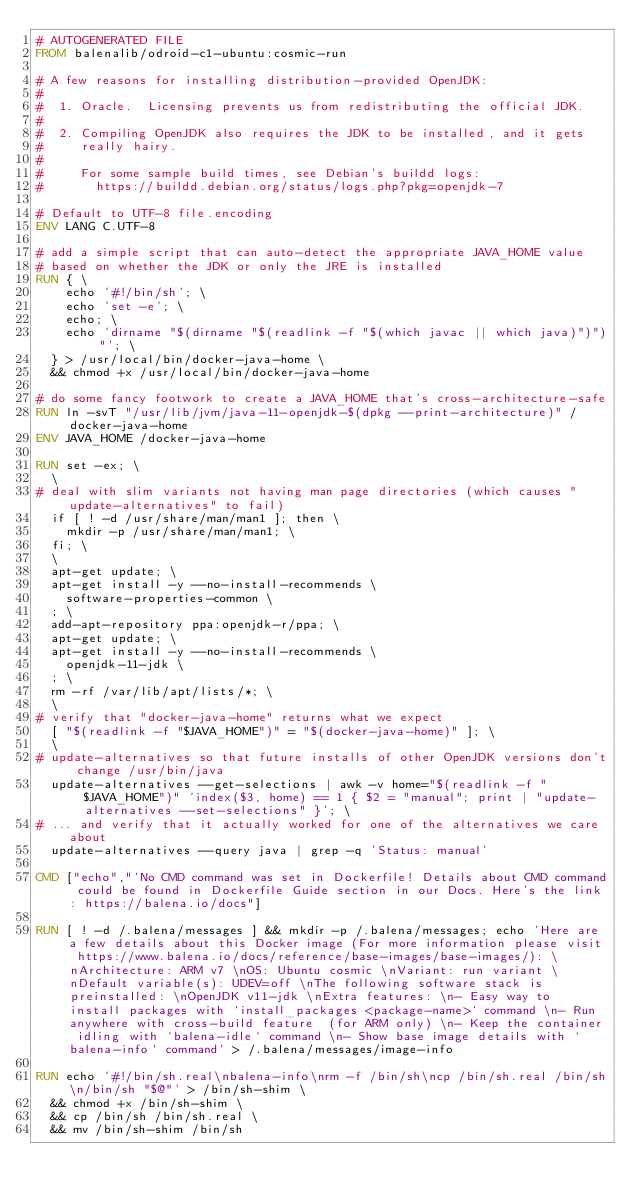<code> <loc_0><loc_0><loc_500><loc_500><_Dockerfile_># AUTOGENERATED FILE
FROM balenalib/odroid-c1-ubuntu:cosmic-run

# A few reasons for installing distribution-provided OpenJDK:
#
#  1. Oracle.  Licensing prevents us from redistributing the official JDK.
#
#  2. Compiling OpenJDK also requires the JDK to be installed, and it gets
#     really hairy.
#
#     For some sample build times, see Debian's buildd logs:
#       https://buildd.debian.org/status/logs.php?pkg=openjdk-7

# Default to UTF-8 file.encoding
ENV LANG C.UTF-8

# add a simple script that can auto-detect the appropriate JAVA_HOME value
# based on whether the JDK or only the JRE is installed
RUN { \
		echo '#!/bin/sh'; \
		echo 'set -e'; \
		echo; \
		echo 'dirname "$(dirname "$(readlink -f "$(which javac || which java)")")"'; \
	} > /usr/local/bin/docker-java-home \
	&& chmod +x /usr/local/bin/docker-java-home

# do some fancy footwork to create a JAVA_HOME that's cross-architecture-safe
RUN ln -svT "/usr/lib/jvm/java-11-openjdk-$(dpkg --print-architecture)" /docker-java-home
ENV JAVA_HOME /docker-java-home

RUN set -ex; \
	\
# deal with slim variants not having man page directories (which causes "update-alternatives" to fail)
	if [ ! -d /usr/share/man/man1 ]; then \
		mkdir -p /usr/share/man/man1; \
	fi; \
	\
	apt-get update; \
	apt-get install -y --no-install-recommends \
		software-properties-common \
	; \
	add-apt-repository ppa:openjdk-r/ppa; \
	apt-get update; \
	apt-get install -y --no-install-recommends \
		openjdk-11-jdk \
	; \
	rm -rf /var/lib/apt/lists/*; \
	\
# verify that "docker-java-home" returns what we expect
	[ "$(readlink -f "$JAVA_HOME")" = "$(docker-java-home)" ]; \
	\
# update-alternatives so that future installs of other OpenJDK versions don't change /usr/bin/java
	update-alternatives --get-selections | awk -v home="$(readlink -f "$JAVA_HOME")" 'index($3, home) == 1 { $2 = "manual"; print | "update-alternatives --set-selections" }'; \
# ... and verify that it actually worked for one of the alternatives we care about
	update-alternatives --query java | grep -q 'Status: manual'

CMD ["echo","'No CMD command was set in Dockerfile! Details about CMD command could be found in Dockerfile Guide section in our Docs. Here's the link: https://balena.io/docs"]

RUN [ ! -d /.balena/messages ] && mkdir -p /.balena/messages; echo 'Here are a few details about this Docker image (For more information please visit https://www.balena.io/docs/reference/base-images/base-images/): \nArchitecture: ARM v7 \nOS: Ubuntu cosmic \nVariant: run variant \nDefault variable(s): UDEV=off \nThe following software stack is preinstalled: \nOpenJDK v11-jdk \nExtra features: \n- Easy way to install packages with `install_packages <package-name>` command \n- Run anywhere with cross-build feature  (for ARM only) \n- Keep the container idling with `balena-idle` command \n- Show base image details with `balena-info` command' > /.balena/messages/image-info

RUN echo '#!/bin/sh.real\nbalena-info\nrm -f /bin/sh\ncp /bin/sh.real /bin/sh\n/bin/sh "$@"' > /bin/sh-shim \
	&& chmod +x /bin/sh-shim \
	&& cp /bin/sh /bin/sh.real \
	&& mv /bin/sh-shim /bin/sh</code> 